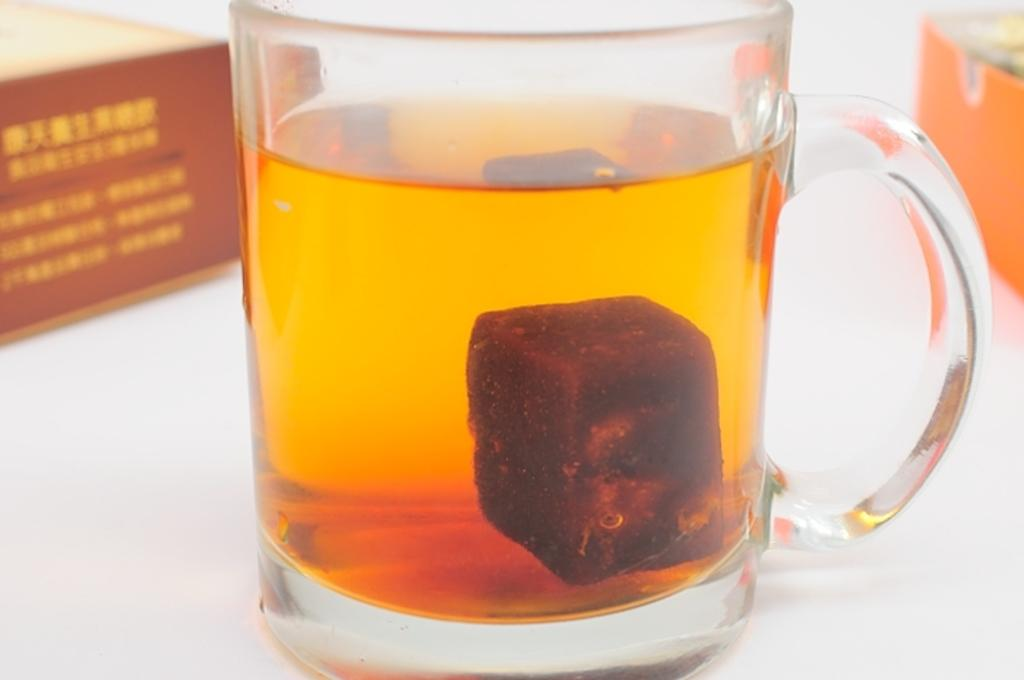What object is present in the image that can hold a liquid? There is a glass in the image. What feature does the glass have that makes it easier to hold? The glass has a handle. What is inside the glass? There is a liquid inside the glass. What type of dress is the glass wearing in the image? The glass is not wearing a dress, as it is an inanimate object and does not have clothing. 